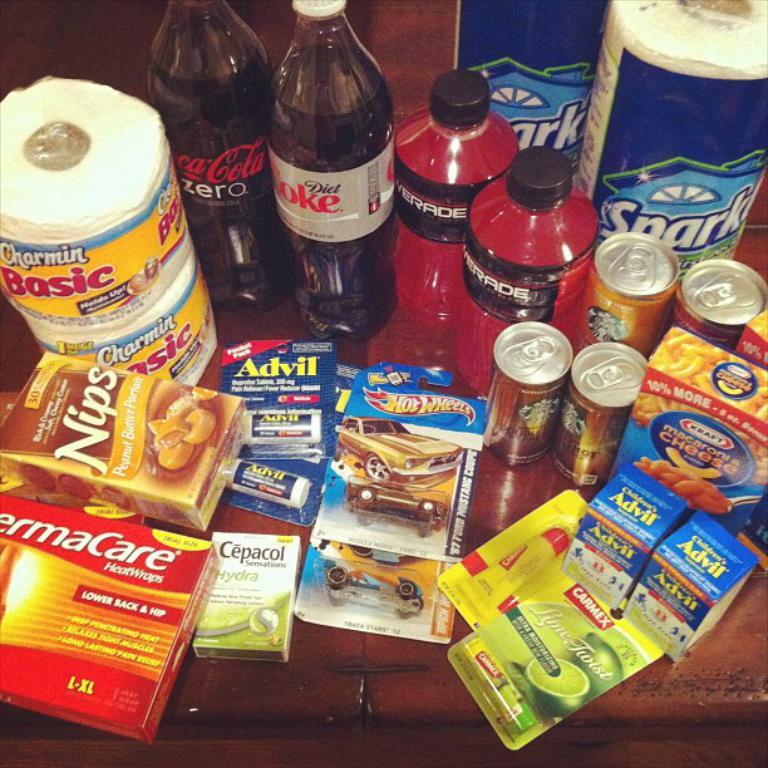<image>
Write a terse but informative summary of the picture. A coke zero and a diet coke are next to each other on a table full of items. 